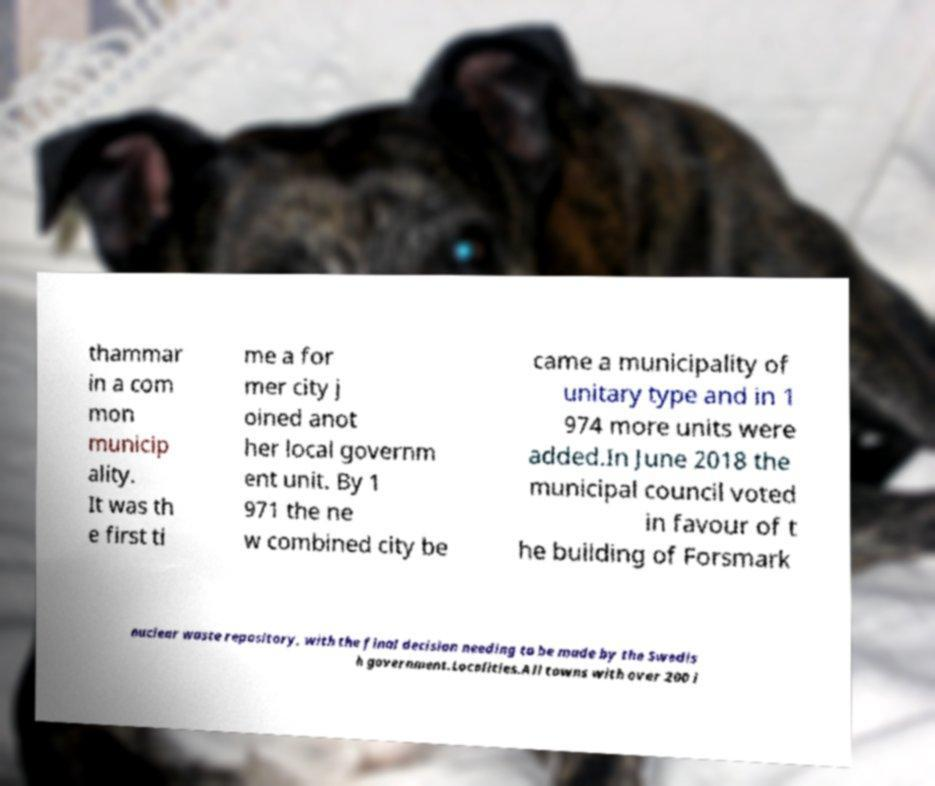Please identify and transcribe the text found in this image. thammar in a com mon municip ality. It was th e first ti me a for mer city j oined anot her local governm ent unit. By 1 971 the ne w combined city be came a municipality of unitary type and in 1 974 more units were added.In June 2018 the municipal council voted in favour of t he building of Forsmark nuclear waste repository, with the final decision needing to be made by the Swedis h government.Localities.All towns with over 200 i 